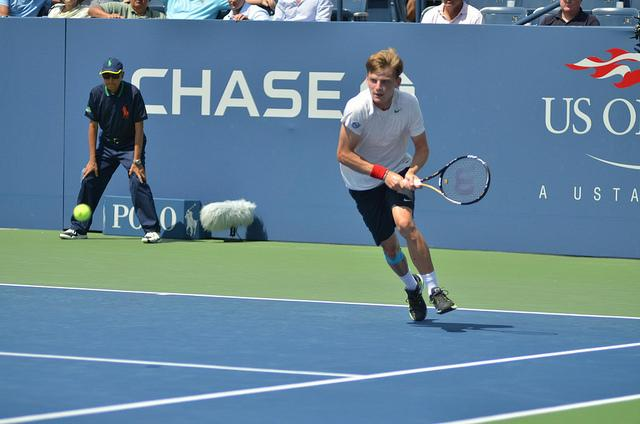What is he doing? playing tennis 